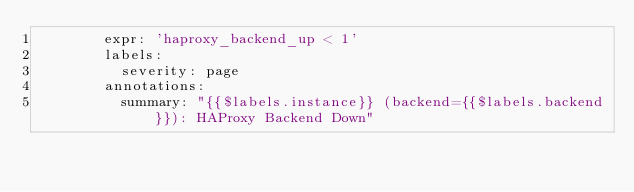<code> <loc_0><loc_0><loc_500><loc_500><_YAML_>        expr: 'haproxy_backend_up < 1'
        labels:
          severity: page
        annotations:
          summary: "{{$labels.instance}} (backend={{$labels.backend}}): HAProxy Backend Down"

</code> 